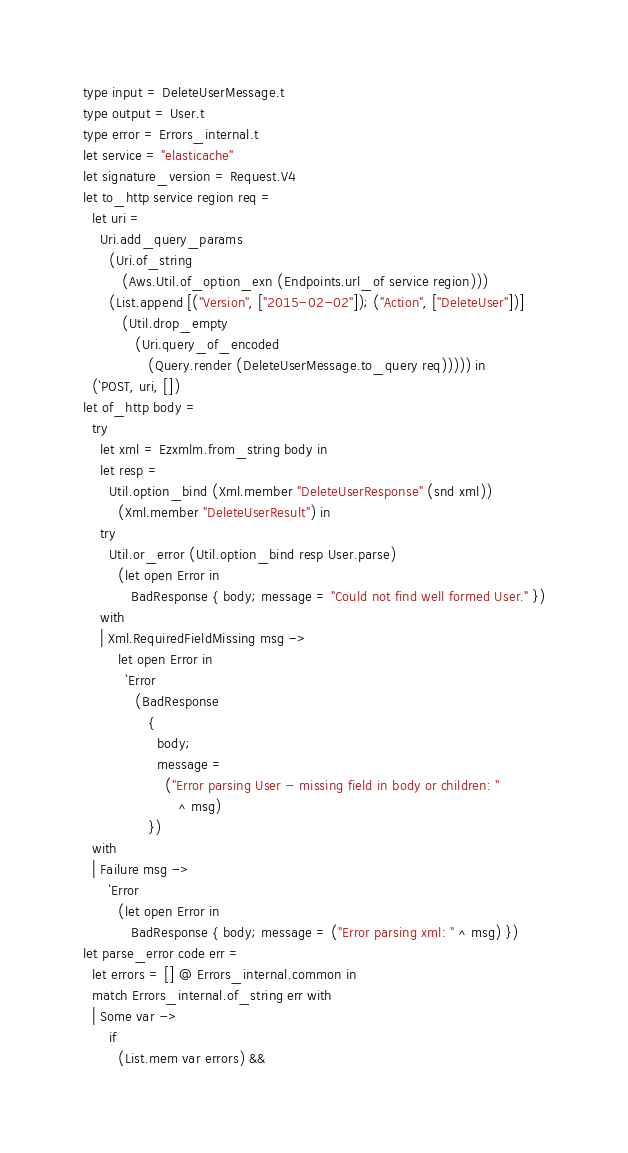<code> <loc_0><loc_0><loc_500><loc_500><_OCaml_>type input = DeleteUserMessage.t
type output = User.t
type error = Errors_internal.t
let service = "elasticache"
let signature_version = Request.V4
let to_http service region req =
  let uri =
    Uri.add_query_params
      (Uri.of_string
         (Aws.Util.of_option_exn (Endpoints.url_of service region)))
      (List.append [("Version", ["2015-02-02"]); ("Action", ["DeleteUser"])]
         (Util.drop_empty
            (Uri.query_of_encoded
               (Query.render (DeleteUserMessage.to_query req))))) in
  (`POST, uri, [])
let of_http body =
  try
    let xml = Ezxmlm.from_string body in
    let resp =
      Util.option_bind (Xml.member "DeleteUserResponse" (snd xml))
        (Xml.member "DeleteUserResult") in
    try
      Util.or_error (Util.option_bind resp User.parse)
        (let open Error in
           BadResponse { body; message = "Could not find well formed User." })
    with
    | Xml.RequiredFieldMissing msg ->
        let open Error in
          `Error
            (BadResponse
               {
                 body;
                 message =
                   ("Error parsing User - missing field in body or children: "
                      ^ msg)
               })
  with
  | Failure msg ->
      `Error
        (let open Error in
           BadResponse { body; message = ("Error parsing xml: " ^ msg) })
let parse_error code err =
  let errors = [] @ Errors_internal.common in
  match Errors_internal.of_string err with
  | Some var ->
      if
        (List.mem var errors) &&</code> 